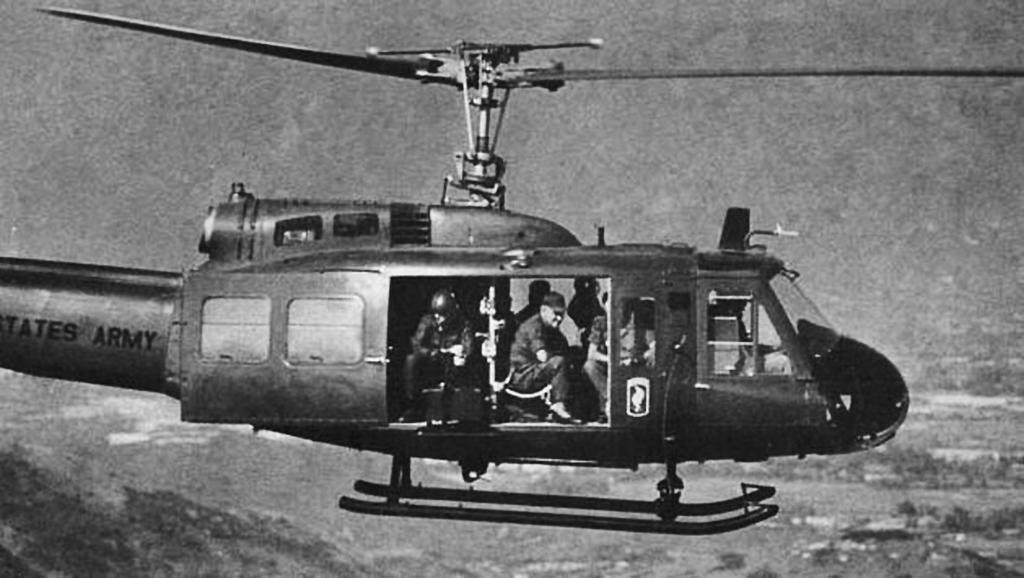What are the people in the image doing? The people in the image are sitting in a helicopter. What is the color scheme of the image? The image is black and white. Can you hear the birds crying in the image? There are no birds or any sounds mentioned in the image, so it's not possible to determine if they are crying. 